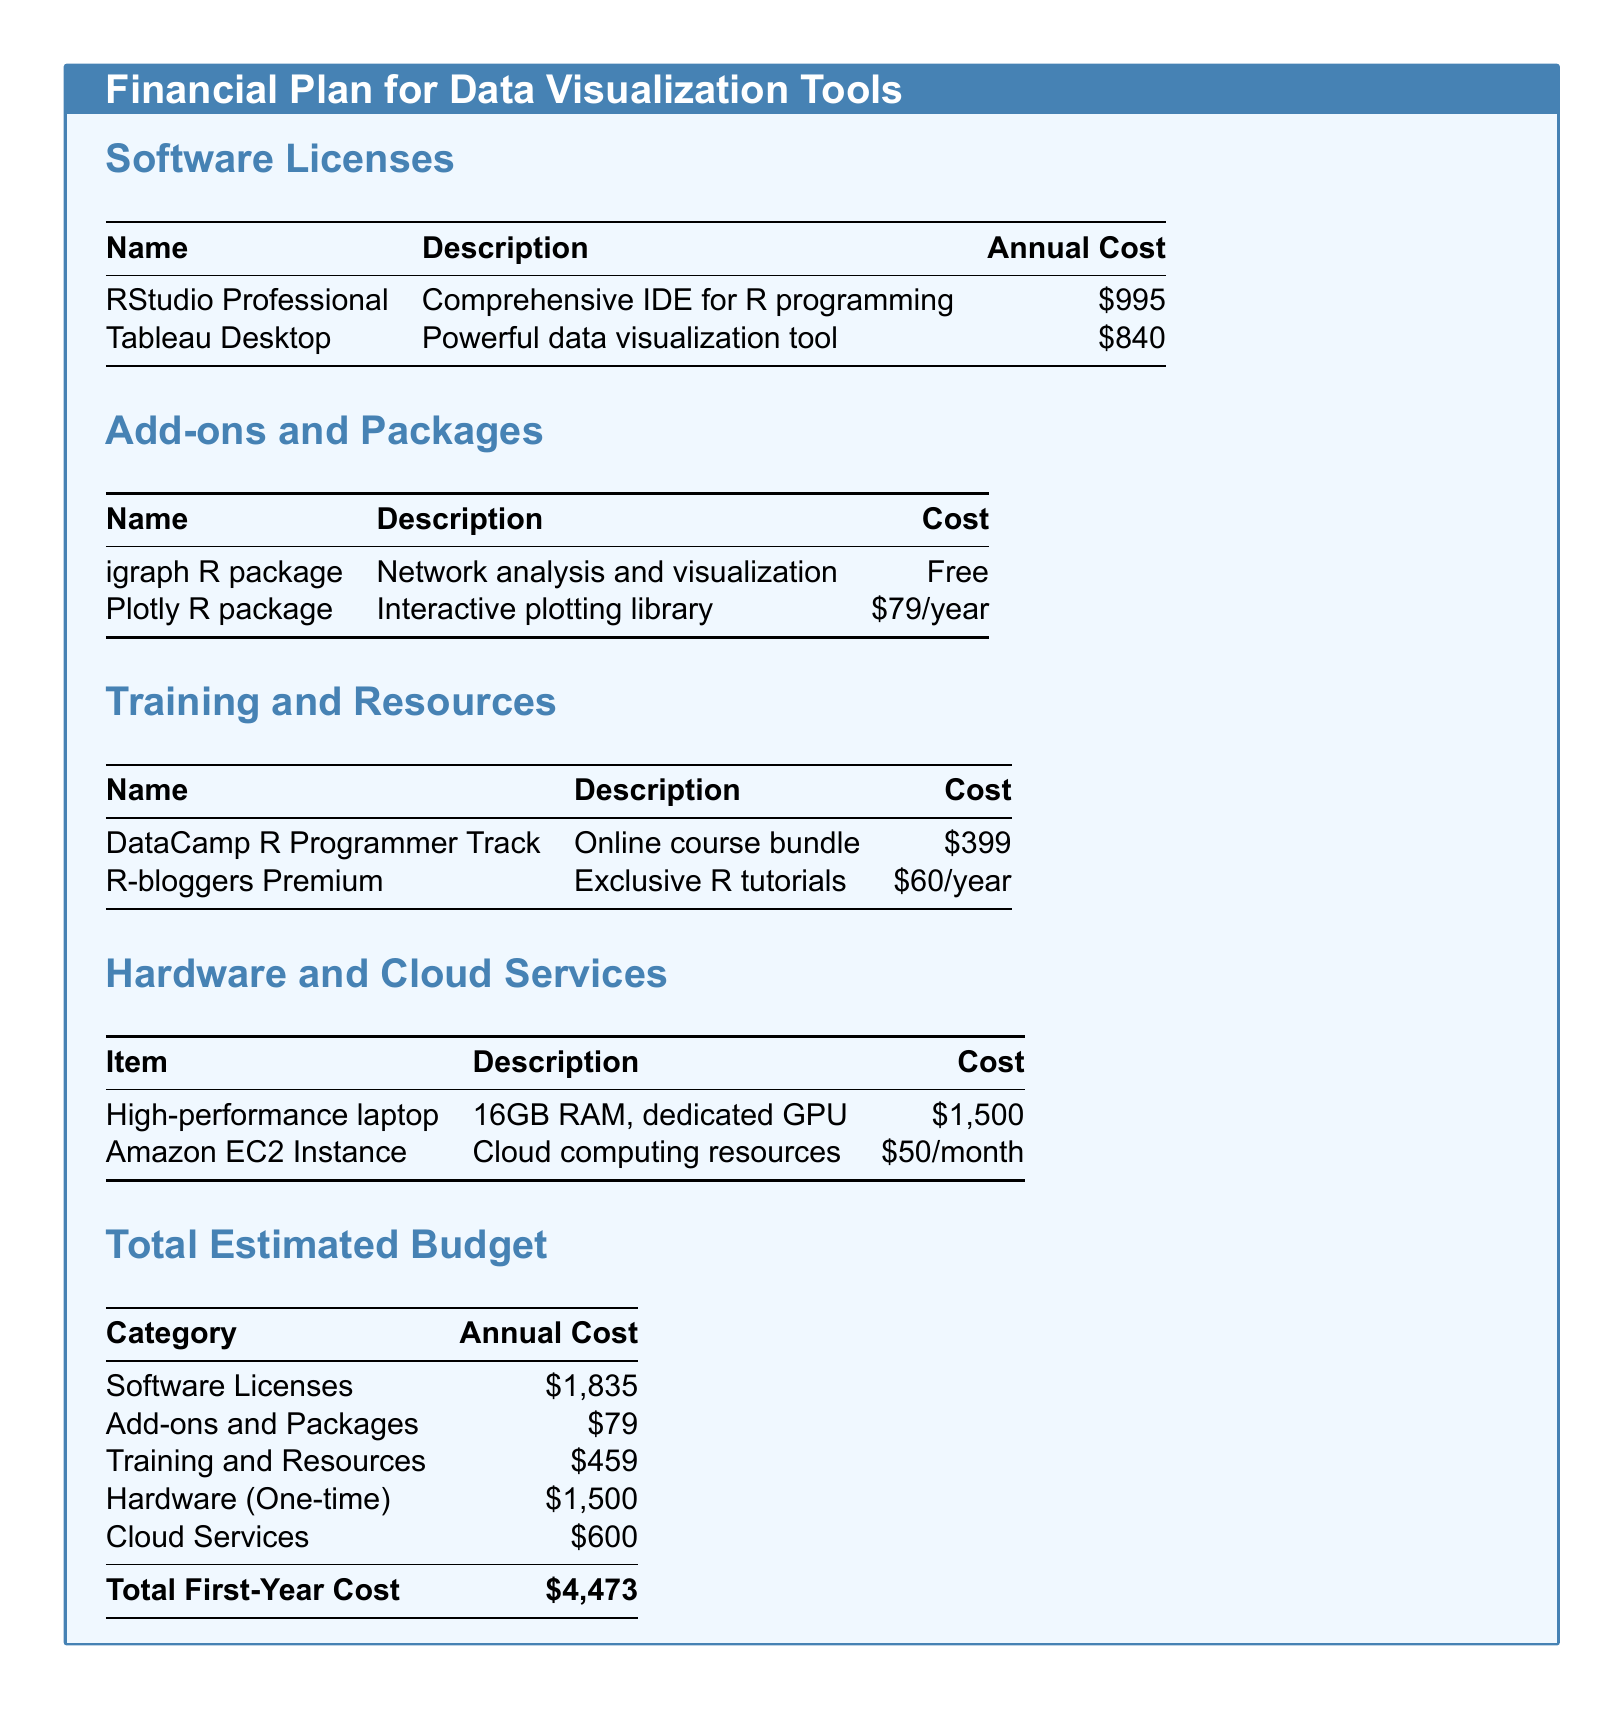What is the annual cost of RStudio Professional? The annual cost of RStudio Professional is explicitly listed in the software licenses section of the document.
Answer: $995 What is the cost of the Plotly R package? The cost of the Plotly R package is mentioned in the add-ons and packages section of the document.
Answer: $79/year What is the total estimated budget for the first year? The total estimated budget for the first year is calculated from the various categories outlined in the document.
Answer: $4,473 How much does the Amazon EC2 Instance cost per month? The monthly cost of the Amazon EC2 Instance is specified in the hardware and cloud services section of the document.
Answer: $50/month What is the total cost of training and resources? The total cost of training and resources is the sum of the costs listed in that specific section of the document.
Answer: $459 Which software has the highest annual cost? The comparison of annual costs in the software licenses section reveals that one software has the highest cost.
Answer: RStudio Professional What is the total cost of hardware? The total cost listed for hardware in the hardware and cloud services section of the document is a one-time cost.
Answer: $1,500 Is the igraph R package free or paid? The pricing information in the add-ons and packages section indicates the cost of the igraph R package.
Answer: Free What type of course does DataCamp offer? The description of the DataCamp offering in the training and resources section indicates the nature of the course.
Answer: Online course bundle 